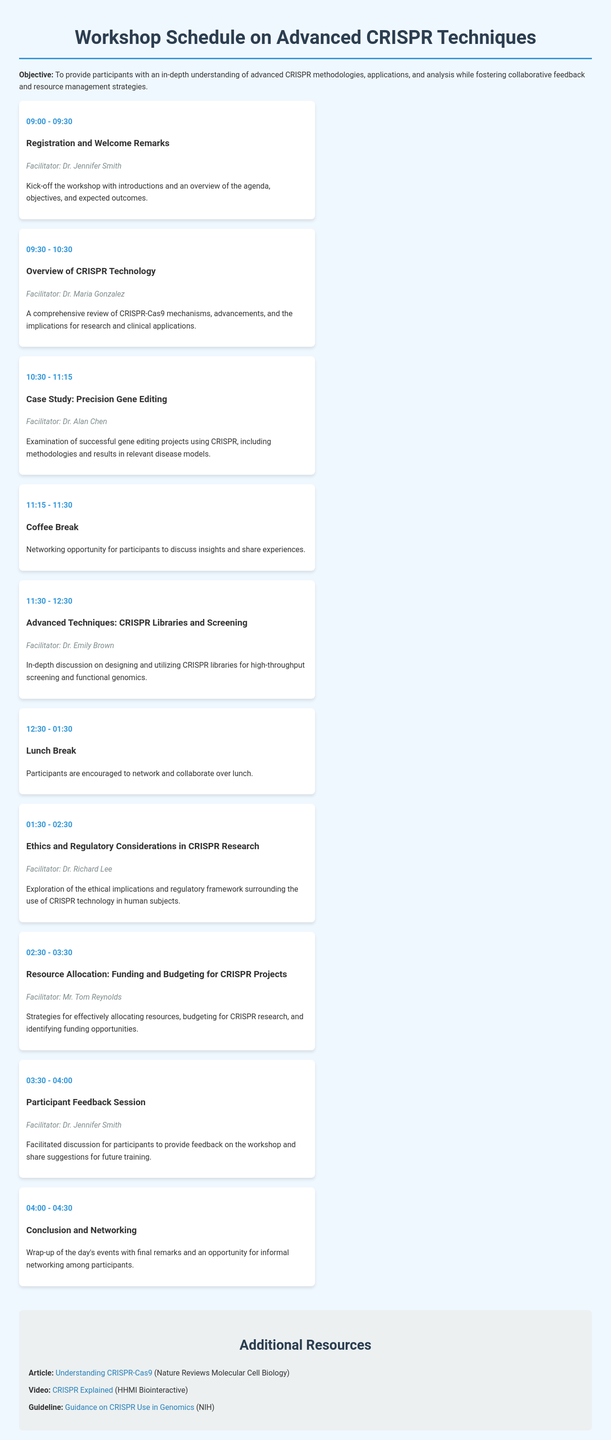What time does the workshop start? The workshop starts at 09:00, as indicated in the schedule.
Answer: 09:00 Who is the facilitator for the Lunch Break session? The Lunch Break session does not have a specific facilitator mentioned in the document.
Answer: None What is the title of the session from 01:30 to 02:30? The title of the session is presented as "Ethics and Regulatory Considerations in CRISPR Research."
Answer: Ethics and Regulatory Considerations in CRISPR Research How long is the Coffee Break scheduled for? The Coffee Break is scheduled to last for 15 minutes, from 11:15 to 11:30.
Answer: 15 minutes Which session focuses on funding and budgeting for CRISPR projects? The session titled "Resource Allocation: Funding and Budgeting for CRISPR Projects" addresses this topic.
Answer: Resource Allocation: Funding and Budgeting for CRISPR Projects What type of resources are provided in the Additional Resources section? The resources include an article, a video, and a guideline related to CRISPR technology.
Answer: Article, Video, Guideline Who facilitates the Participant Feedback Session? The Participant Feedback Session is facilitated by Dr. Jennifer Smith, as stated in the document.
Answer: Dr. Jennifer Smith What is the objective of the workshop? The objective is to provide participants with an in-depth understanding of advanced CRISPR methodologies, applications, and analysis.
Answer: In-depth understanding of advanced CRISPR methodologies, applications, and analysis 